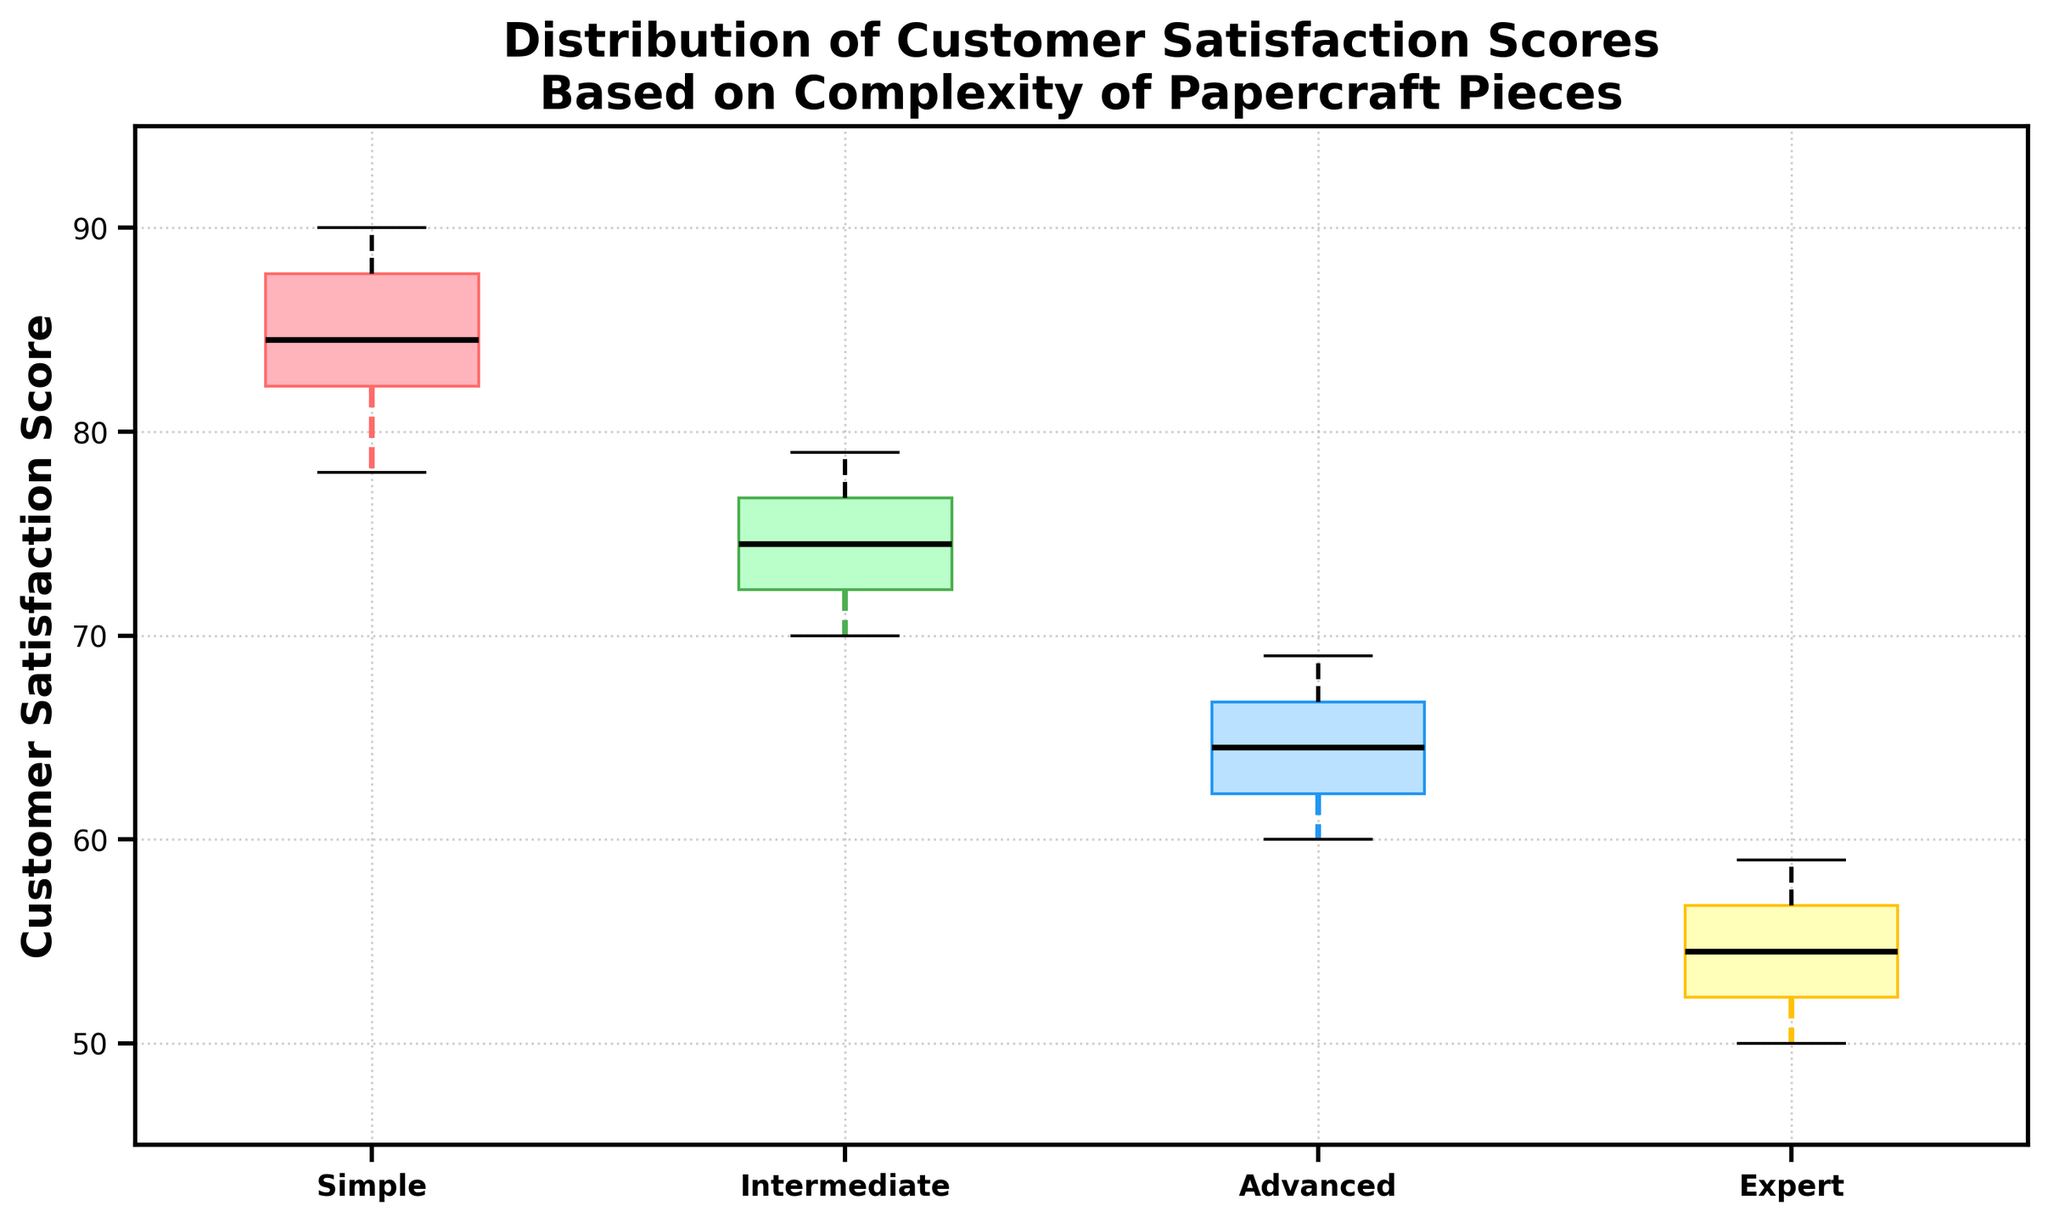What's the title of the figure? The title is usually located at the top of the figure. For this specific figure, the title provided is "Distribution of Customer Satisfaction Scores Based on Complexity of Papercraft Pieces".
Answer: Distribution of Customer Satisfaction Scores Based on Complexity of Papercraft Pieces What is the mean of Customer Satisfaction Scores for the 'Intermediate' group? To find the mean, sum up all satisfaction scores for this group and divide by the number of scores. For 'Intermediate': (70 + 75 + 78 + 72 + 74 + 76 + 73 + 71 + 77 + 79) / 10 = 745 / 10 = 74.5
Answer: 74.5 Which boxplot group has the highest median satisfaction score? Identify the black line inside each boxplot, which represents the median. Comparing the positions of these lines, the 'Simple' group has the highest median at a higher value on the y-axis.
Answer: Simple What are the upper and lower quartiles of the 'Advanced' boxplot? Quartiles are edges of the box in a boxplot. The lower quartile (Q1) is at around 62, and the upper quartile (Q3) is at around 67 as observed from the box edges for 'Advanced'.
Answer: Q1: 62, Q3: 67 Which group shows the widest range in customer satisfaction scores? The range is calculated by the difference between the maximum and minimum scores (whiskers). The 'Expert' group shows the widest range, from around 50 to 59.
Answer: Expert Is the median customer satisfaction score higher for 'Simple' or 'Advanced' complexity? Compare the black lines (medians) inside the boxes for 'Simple' and 'Advanced'. The median for 'Simple' is higher than for 'Advanced'.
Answer: Simple What is the overall trend in customer satisfaction scores as the complexity of papercraft pieces increases? Observe the trend of medians and quartiles for each group. As complexity increases from 'Simple' to 'Expert', customer satisfaction scores generally decrease.
Answer: Decreasing What are the interquartile ranges (IQRs) for 'Intermediate' and 'Expert' groups? The IQR is calculated by subtracting Q1 from Q3. For 'Intermediate', Q3 ≈ 77 and Q1 ≈ 72 (IQR = 77 - 72 = 5). For 'Expert', Q3 ≈ 57 and Q1 ≈ 52 (IQR = 57 - 52 = 5).
Answer: 5 for both Which group has the smallest variability in customer satisfaction scores? Variability can be assessed by the length of the box and whiskers. The 'Intermediate' group has the smallest range, indicated by the shortest whiskers.
Answer: Intermediate 